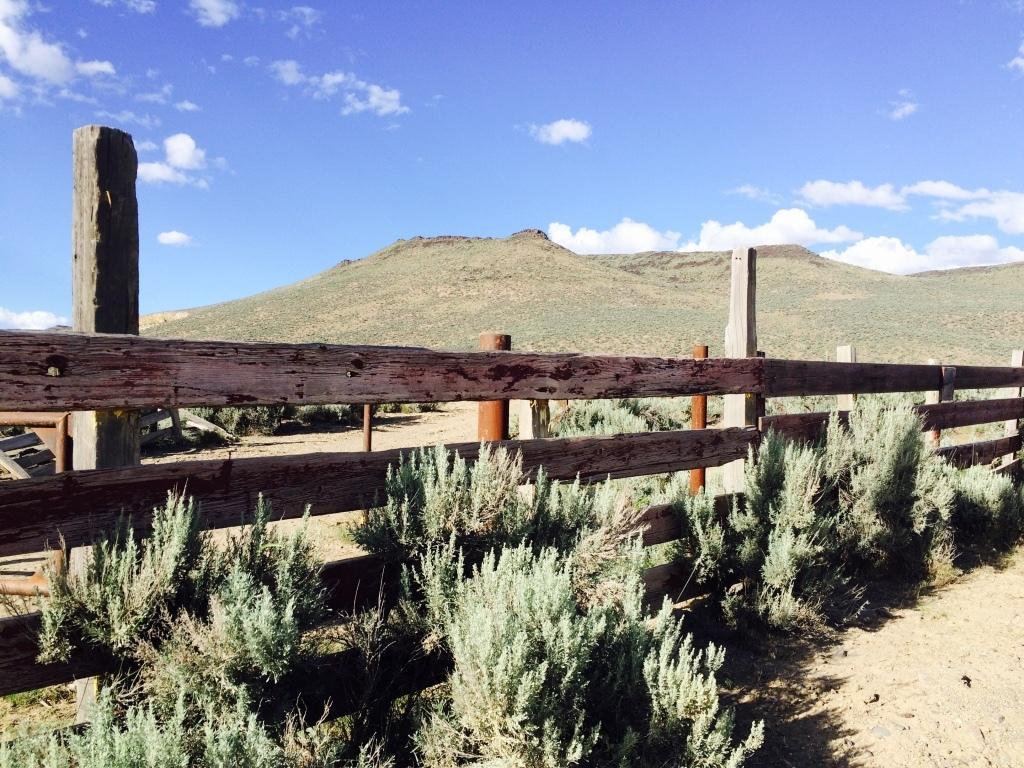What type of living organisms can be seen in the image? Plants can be seen in the image. What type of barrier is present in the image? There is a wooden fence in the image. What natural features can be seen in the background of the image? Mountains and the sky are visible in the background of the image. What type of pest is attacking the lettuce in the image? There is no lettuce present in the image, and therefore no pest can be observed attacking it. 